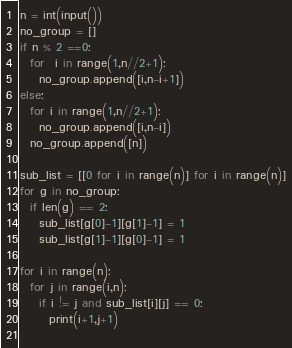<code> <loc_0><loc_0><loc_500><loc_500><_Python_>n = int(input())
no_group = []
if n % 2 ==0:
  for  i in range(1,n//2+1):
    no_group.append([i,n-i+1])
else:
  for i in range(1,n//2+1):
    no_group.append([i,n-i])
  no_group.append([n])
  
sub_list = [[0 for i in range(n)] for i in range(n)]
for g in no_group:
  if len(g) == 2:
    sub_list[g[0]-1][g[1]-1] = 1
    sub_list[g[1]-1][g[0]-1] = 1

for i in range(n):
  for j in range(i,n):
    if i != j and sub_list[i][j] == 0:
      print(i+1,j+1)
    </code> 